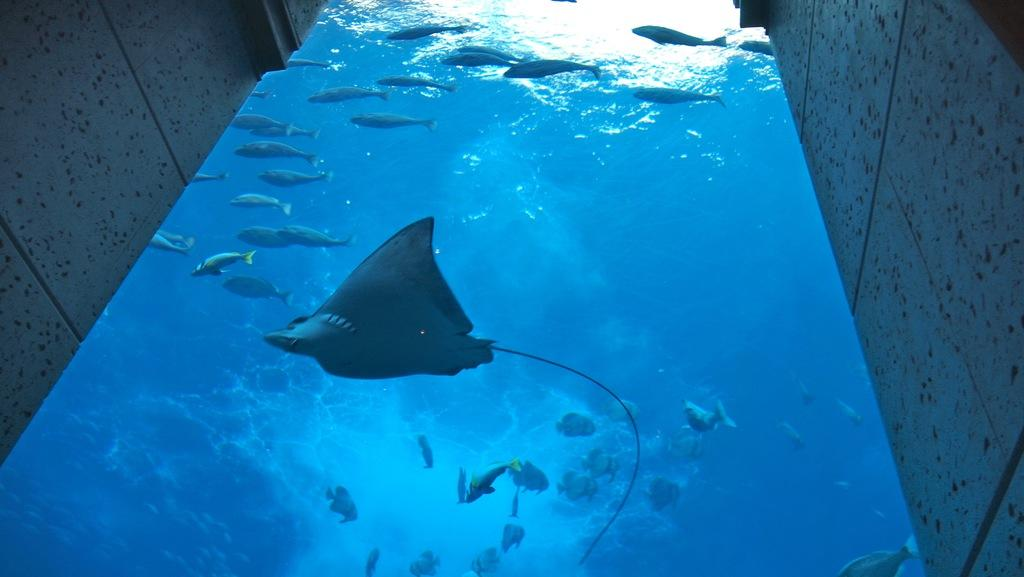What type of animals can be seen in the water in the image? There are fish and sea animals in the water in the image. What is the surrounding environment of the water in the image? There are walls visible on the left and right sides of the image. What is the cause of the cough in the image? There is no cough present in the image, as it features fish and sea animals in the water with walls on the left and right sides. 